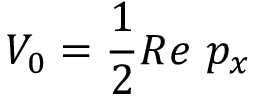Convert formula to latex. <formula><loc_0><loc_0><loc_500><loc_500>V _ { 0 } = \frac { 1 } { 2 } R e \ p _ { x }</formula> 